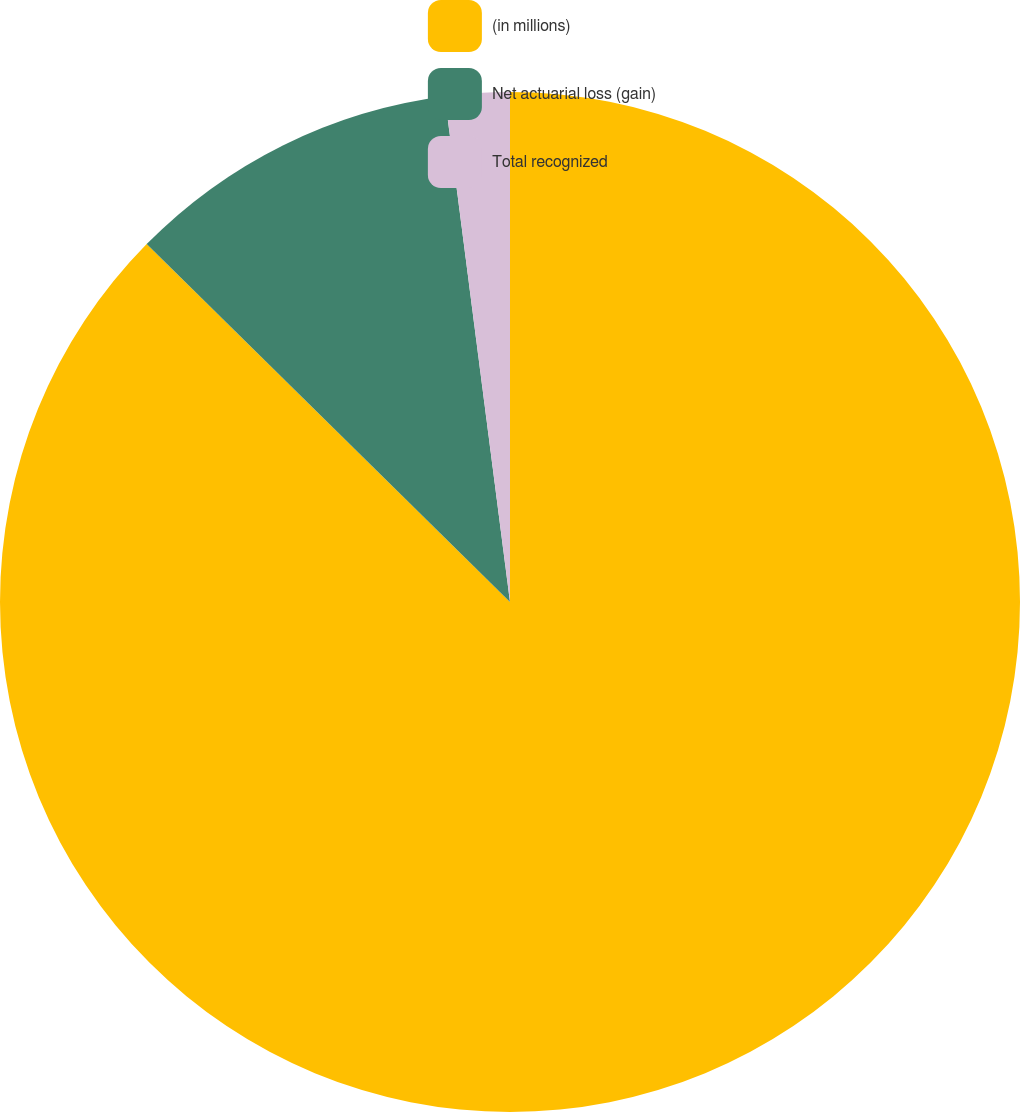Convert chart. <chart><loc_0><loc_0><loc_500><loc_500><pie_chart><fcel>(in millions)<fcel>Net actuarial loss (gain)<fcel>Total recognized<nl><fcel>87.38%<fcel>10.58%<fcel>2.04%<nl></chart> 